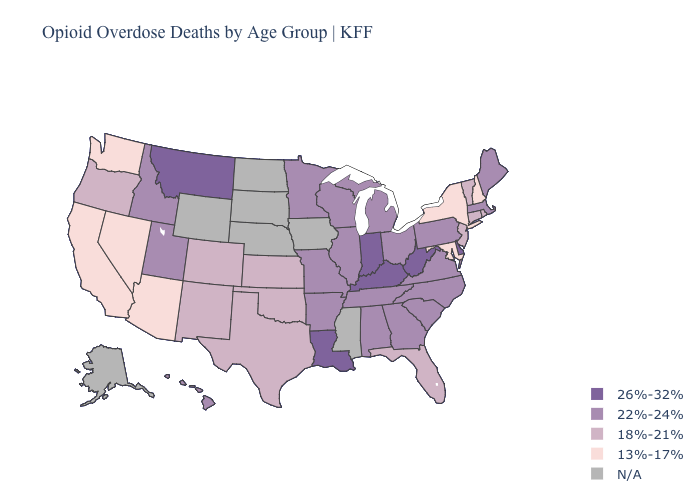Does Vermont have the lowest value in the USA?
Short answer required. No. What is the lowest value in the USA?
Short answer required. 13%-17%. Does New Jersey have the highest value in the Northeast?
Keep it brief. No. Name the states that have a value in the range 13%-17%?
Give a very brief answer. Arizona, California, Maryland, Nevada, New Hampshire, New York, Washington. What is the highest value in states that border Nevada?
Short answer required. 22%-24%. What is the lowest value in states that border West Virginia?
Write a very short answer. 13%-17%. Name the states that have a value in the range 18%-21%?
Quick response, please. Colorado, Connecticut, Florida, Kansas, New Jersey, New Mexico, Oklahoma, Oregon, Rhode Island, Texas, Vermont. Which states have the highest value in the USA?
Give a very brief answer. Delaware, Indiana, Kentucky, Louisiana, Montana, West Virginia. Does Massachusetts have the highest value in the Northeast?
Answer briefly. Yes. Does Maryland have the lowest value in the South?
Give a very brief answer. Yes. What is the value of North Carolina?
Quick response, please. 22%-24%. Name the states that have a value in the range 22%-24%?
Concise answer only. Alabama, Arkansas, Georgia, Hawaii, Idaho, Illinois, Maine, Massachusetts, Michigan, Minnesota, Missouri, North Carolina, Ohio, Pennsylvania, South Carolina, Tennessee, Utah, Virginia, Wisconsin. What is the highest value in the USA?
Concise answer only. 26%-32%. 